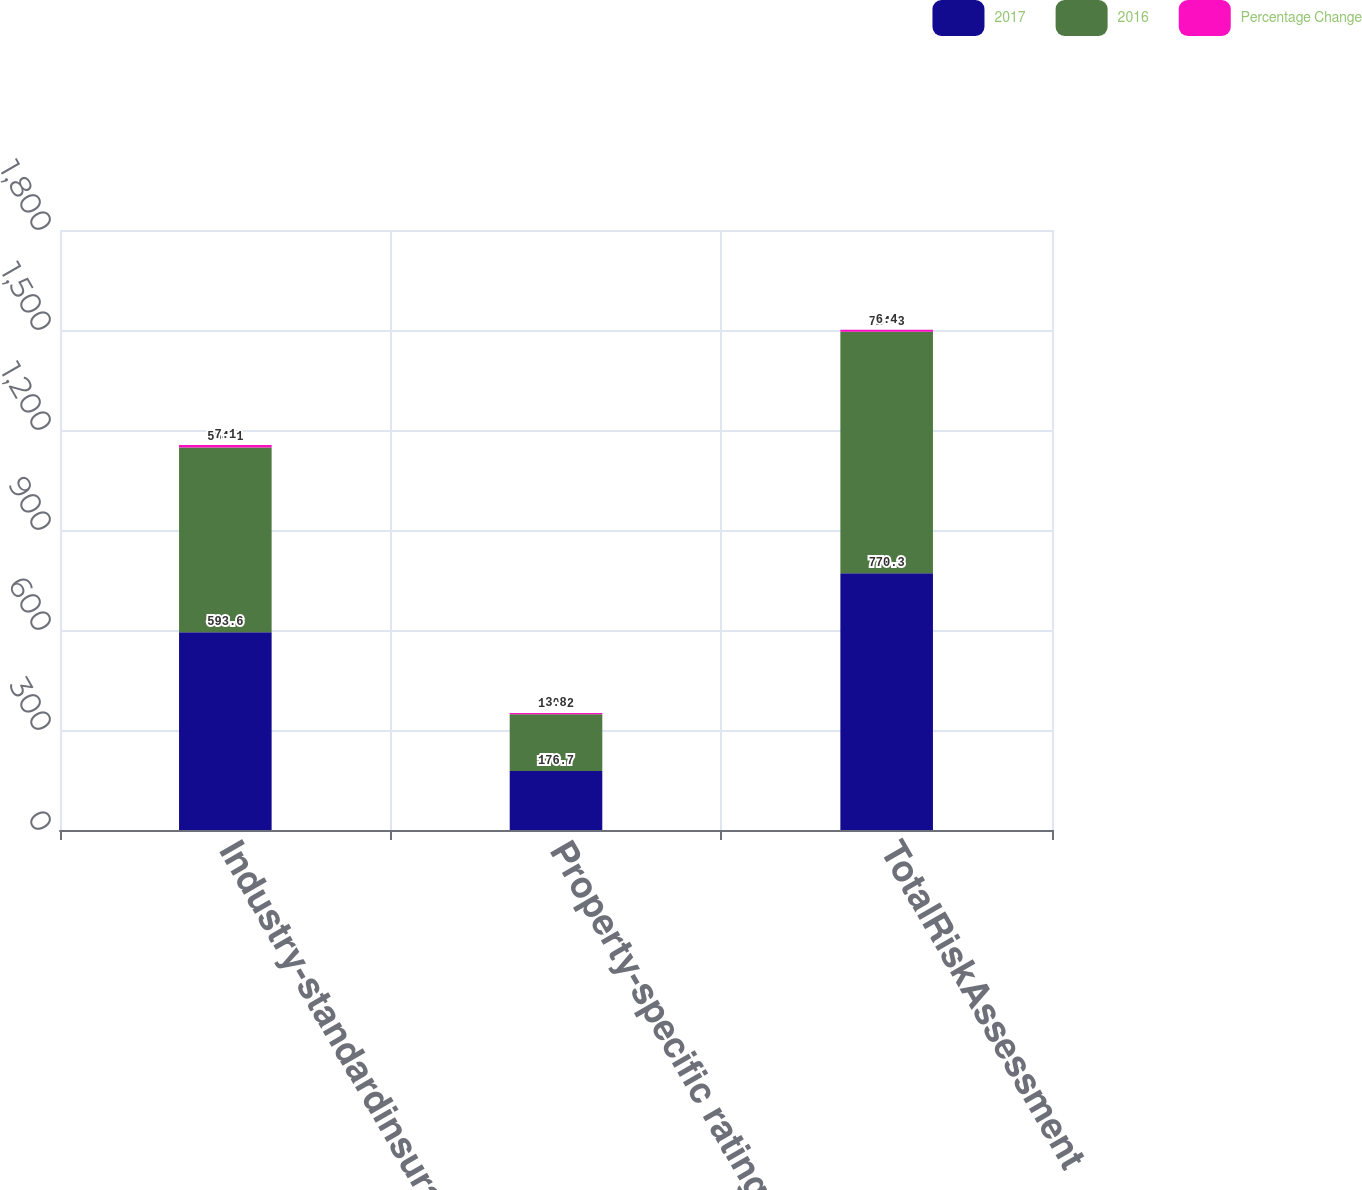<chart> <loc_0><loc_0><loc_500><loc_500><stacked_bar_chart><ecel><fcel>Industry-standardinsurance<fcel>Property-specific rating and<fcel>TotalRiskAssessment<nl><fcel>2017<fcel>593.6<fcel>176.7<fcel>770.3<nl><fcel>2016<fcel>554.1<fcel>170.2<fcel>724.3<nl><fcel>Percentage Change<fcel>7.1<fcel>3.8<fcel>6.4<nl></chart> 